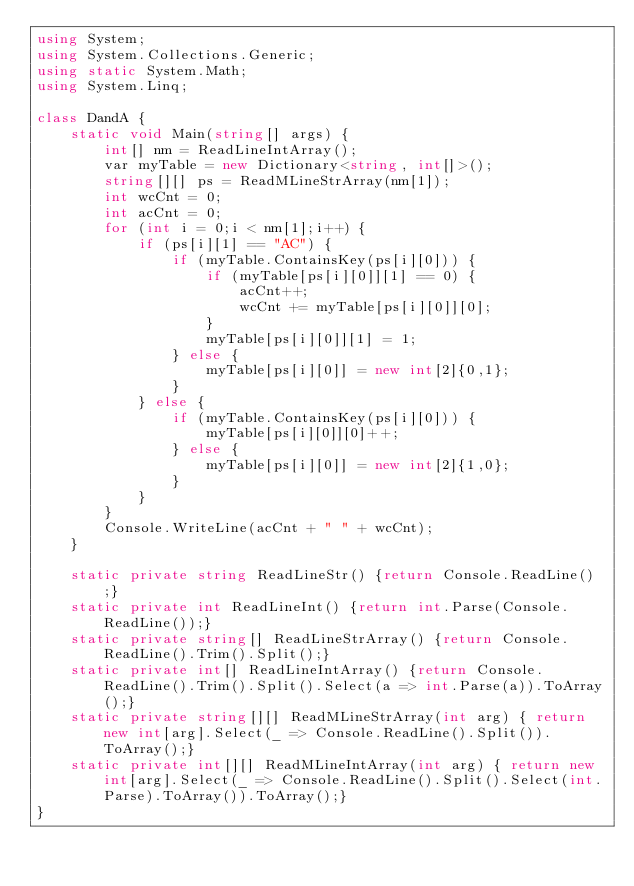<code> <loc_0><loc_0><loc_500><loc_500><_C#_>using System;
using System.Collections.Generic;
using static System.Math;
using System.Linq;
 
class DandA {
    static void Main(string[] args) {
        int[] nm = ReadLineIntArray();
        var myTable = new Dictionary<string, int[]>();
        string[][] ps = ReadMLineStrArray(nm[1]);
        int wcCnt = 0;
        int acCnt = 0;
        for (int i = 0;i < nm[1];i++) {
            if (ps[i][1] == "AC") {
                if (myTable.ContainsKey(ps[i][0])) {
                    if (myTable[ps[i][0]][1] == 0) {
                        acCnt++;
                        wcCnt += myTable[ps[i][0]][0];
                    }
                    myTable[ps[i][0]][1] = 1;
                } else {
                    myTable[ps[i][0]] = new int[2]{0,1};
                }
            } else {
                if (myTable.ContainsKey(ps[i][0])) {
                    myTable[ps[i][0]][0]++;
                } else {
                    myTable[ps[i][0]] = new int[2]{1,0};
                }
            }
        }
        Console.WriteLine(acCnt + " " + wcCnt);
    }
  
    static private string ReadLineStr() {return Console.ReadLine();}
    static private int ReadLineInt() {return int.Parse(Console.ReadLine());}
    static private string[] ReadLineStrArray() {return Console.ReadLine().Trim().Split();}
    static private int[] ReadLineIntArray() {return Console.ReadLine().Trim().Split().Select(a => int.Parse(a)).ToArray();}
    static private string[][] ReadMLineStrArray(int arg) { return new int[arg].Select(_ => Console.ReadLine().Split()).ToArray();}
    static private int[][] ReadMLineIntArray(int arg) { return new int[arg].Select(_ => Console.ReadLine().Split().Select(int.Parse).ToArray()).ToArray();}
}</code> 